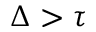Convert formula to latex. <formula><loc_0><loc_0><loc_500><loc_500>\Delta > \tau</formula> 